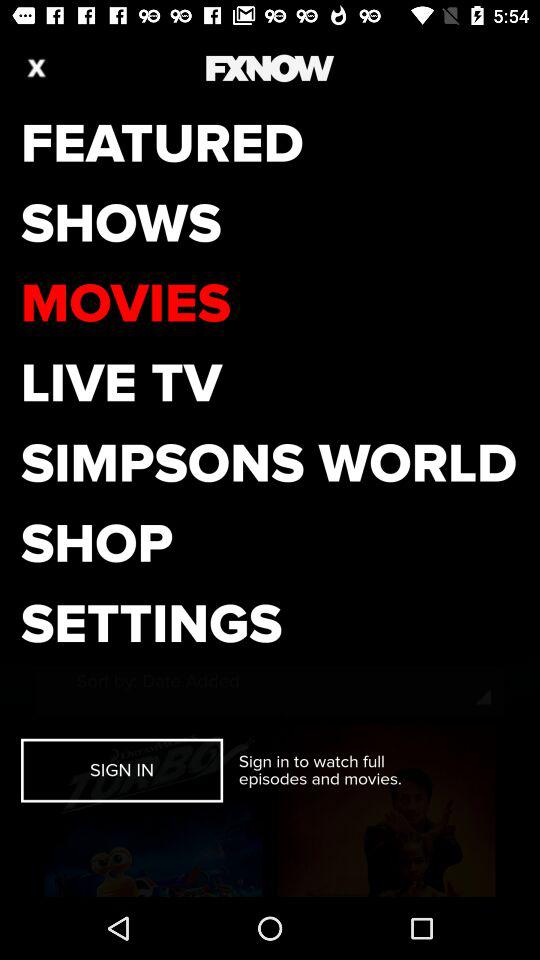How many notifications are there in "SETTINGS"?
When the provided information is insufficient, respond with <no answer>. <no answer> 